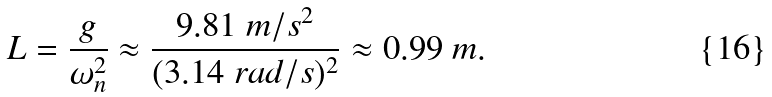<formula> <loc_0><loc_0><loc_500><loc_500>L = { \frac { g } { \omega _ { n } ^ { 2 } } } \approx { \frac { 9 . 8 1 \ m / s ^ { 2 } } { ( 3 . 1 4 \ r a d / s ) ^ { 2 } } } \approx 0 . 9 9 \ m .</formula> 